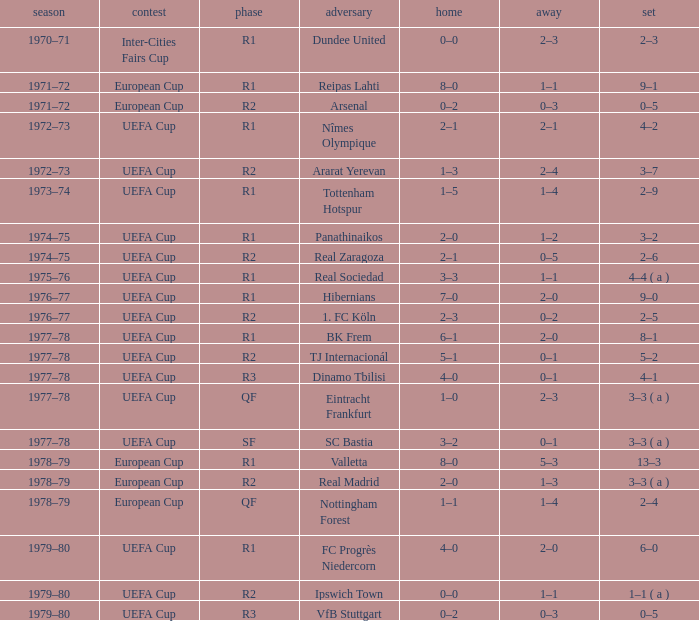Which Opponent has an Away of 1–1, and a Home of 3–3? Real Sociedad. 